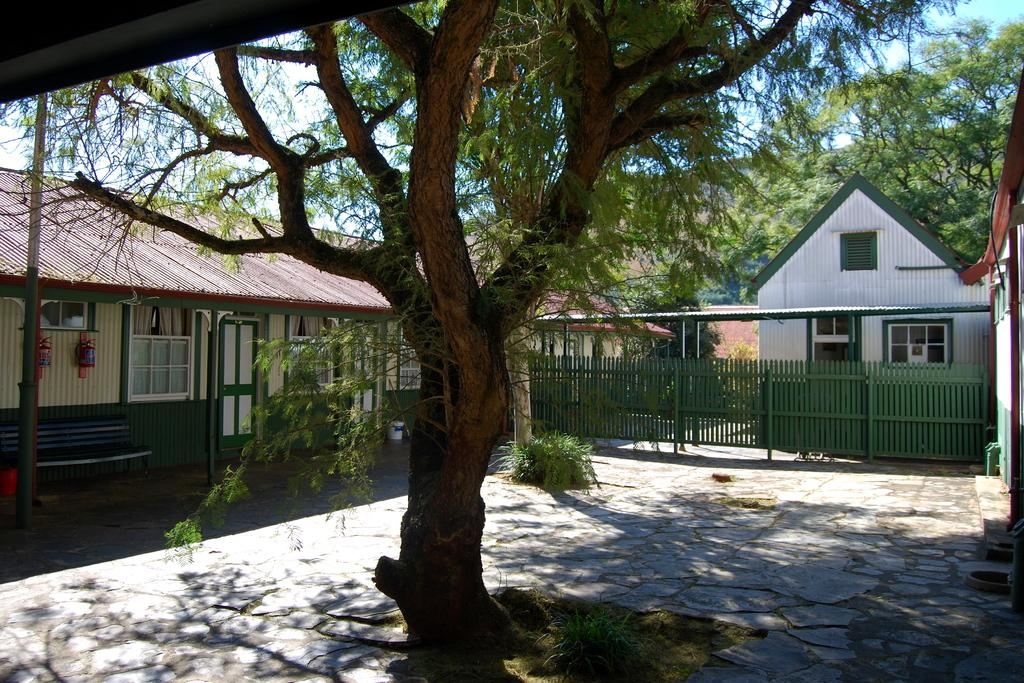What type of structures can be seen in the image? There are buildings in the image. What type of barrier is present in the image? There is fencing in the image. What type of entrance is visible in the image? There is a door in the image. What type of openings are present in the buildings? There are windows in the image. What type of seating is available in the image? There is a bench in the image. What type of vertical supports are present in the image? There are poles in the image. What type of vegetation is present in the image? There are trees and plants in the image. What part of the natural environment is visible in the background of the image? The sky is visible in the background of the image. What type of pancake is being served on the bench in the image? There is no pancake present in the image; it is a bench in a setting with buildings, fencing, doors, windows, poles, trees, plants, and a visible sky. What type of clouds can be seen in the image? The provided facts do not mention any clouds in the image; only the sky is visible in the background. 